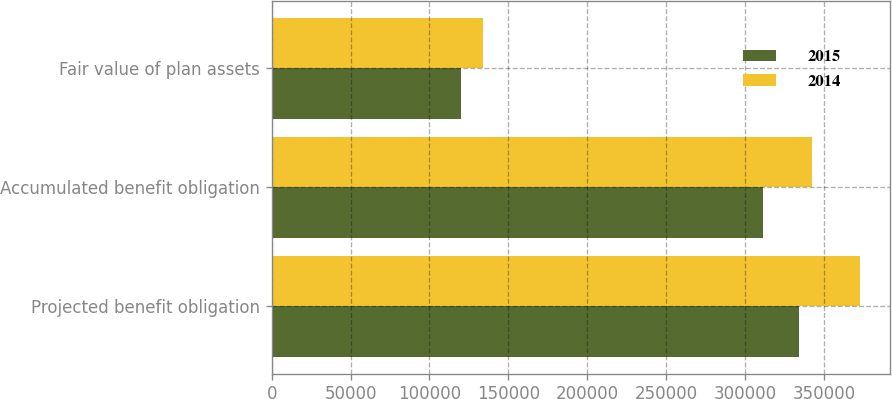Convert chart. <chart><loc_0><loc_0><loc_500><loc_500><stacked_bar_chart><ecel><fcel>Projected benefit obligation<fcel>Accumulated benefit obligation<fcel>Fair value of plan assets<nl><fcel>2015<fcel>333994<fcel>311300<fcel>120069<nl><fcel>2014<fcel>372931<fcel>342158<fcel>133930<nl></chart> 